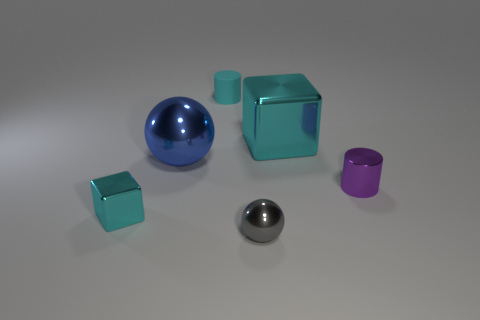Add 1 cylinders. How many objects exist? 7 Subtract all spheres. How many objects are left? 4 Add 6 cylinders. How many cylinders are left? 8 Add 6 gray metallic things. How many gray metallic things exist? 7 Subtract 1 gray balls. How many objects are left? 5 Subtract all large cyan metal objects. Subtract all blocks. How many objects are left? 3 